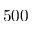Convert formula to latex. <formula><loc_0><loc_0><loc_500><loc_500>5 0 0</formula> 